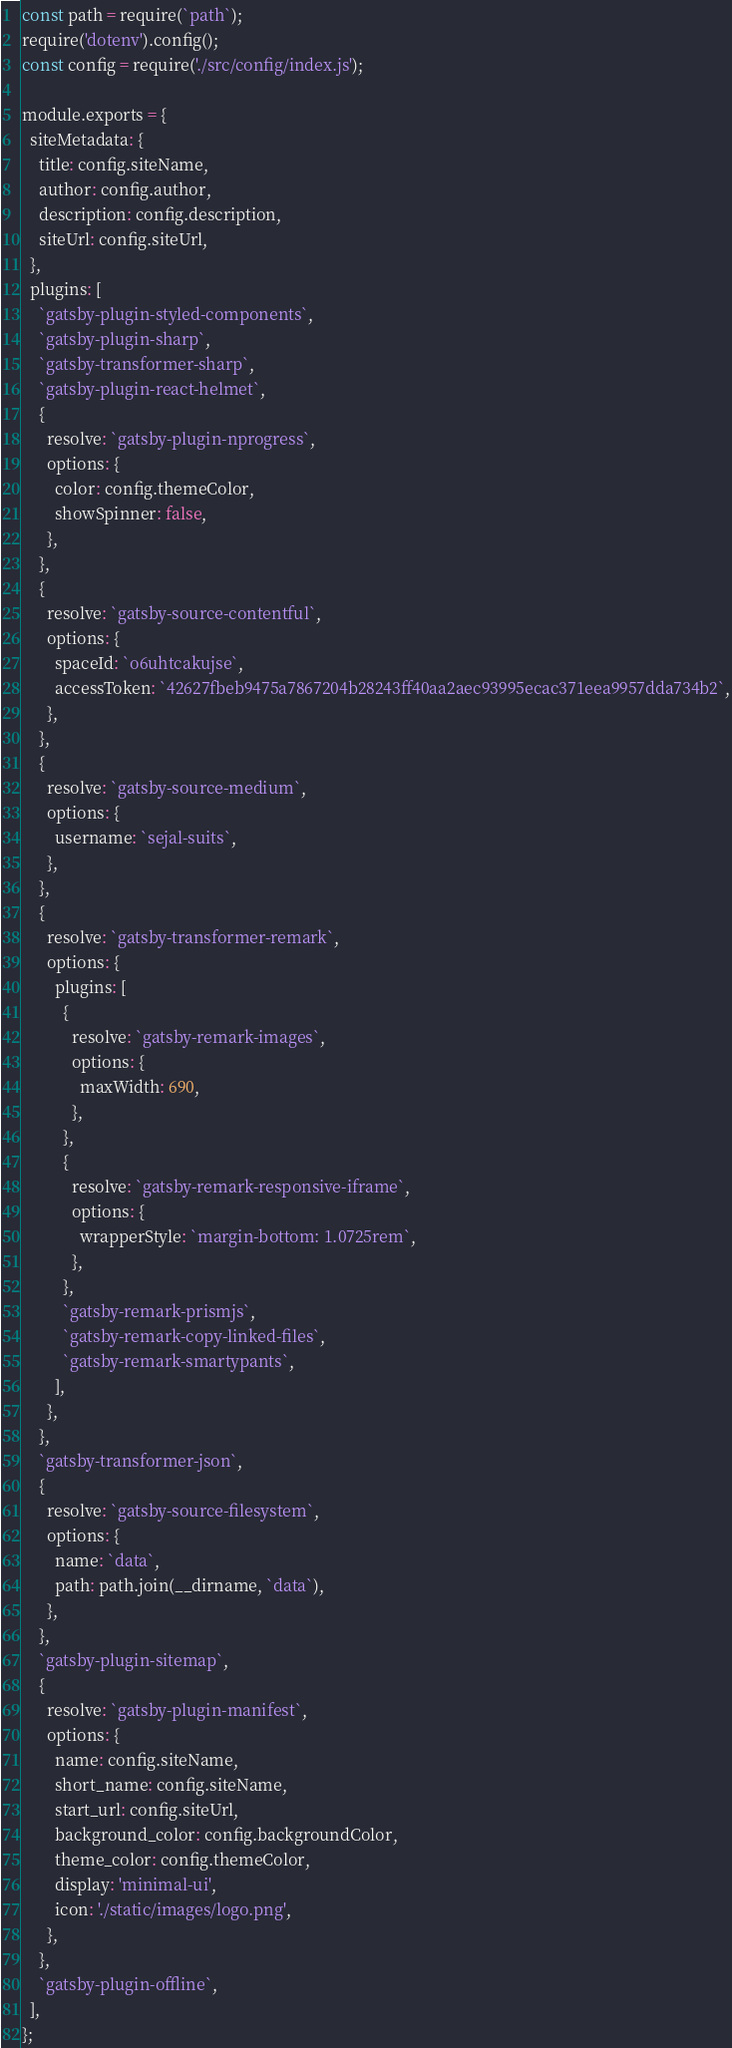Convert code to text. <code><loc_0><loc_0><loc_500><loc_500><_JavaScript_>const path = require(`path`);
require('dotenv').config();
const config = require('./src/config/index.js');

module.exports = {
  siteMetadata: {
    title: config.siteName,
    author: config.author,
    description: config.description,
    siteUrl: config.siteUrl,
  },
  plugins: [
    `gatsby-plugin-styled-components`,
    `gatsby-plugin-sharp`,
    `gatsby-transformer-sharp`,
    `gatsby-plugin-react-helmet`,
    {
      resolve: `gatsby-plugin-nprogress`,
      options: {
        color: config.themeColor,
        showSpinner: false,
      },
    },
    {
      resolve: `gatsby-source-contentful`,
      options: {
        spaceId: `o6uhtcakujse`,
        accessToken: `42627fbeb9475a7867204b28243ff40aa2aec93995ecac371eea9957dda734b2`,
      },
    },
    {
      resolve: `gatsby-source-medium`,
      options: {
        username: `sejal-suits`,
      },
    },
    {
      resolve: `gatsby-transformer-remark`,
      options: {
        plugins: [
          {
            resolve: `gatsby-remark-images`,
            options: {
              maxWidth: 690,
            },
          },
          {
            resolve: `gatsby-remark-responsive-iframe`,
            options: {
              wrapperStyle: `margin-bottom: 1.0725rem`,
            },
          },
          `gatsby-remark-prismjs`,
          `gatsby-remark-copy-linked-files`,
          `gatsby-remark-smartypants`,
        ],
      },
    },
    `gatsby-transformer-json`,
    {
      resolve: `gatsby-source-filesystem`,
      options: {
        name: `data`,
        path: path.join(__dirname, `data`),
      },
    },
    `gatsby-plugin-sitemap`,
    {
      resolve: `gatsby-plugin-manifest`,
      options: {
        name: config.siteName,
        short_name: config.siteName,
        start_url: config.siteUrl,
        background_color: config.backgroundColor,
        theme_color: config.themeColor,
        display: 'minimal-ui',
        icon: './static/images/logo.png',
      },
    },
    `gatsby-plugin-offline`,
  ],
};
</code> 